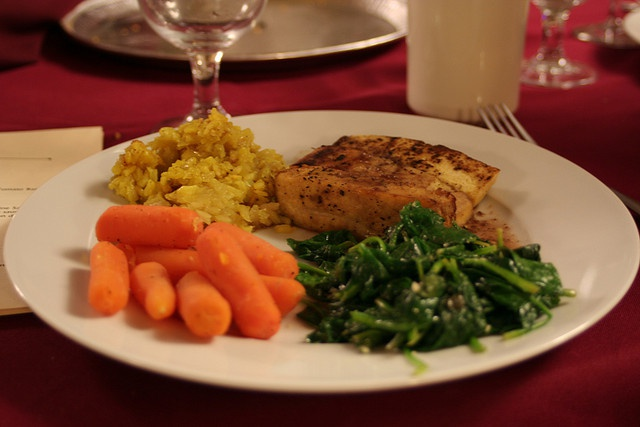Describe the objects in this image and their specific colors. I can see dining table in black, maroon, tan, and brown tones, sandwich in maroon, brown, and tan tones, cup in maroon, gray, brown, and tan tones, carrot in maroon, red, and brown tones, and wine glass in maroon, gray, and brown tones in this image. 